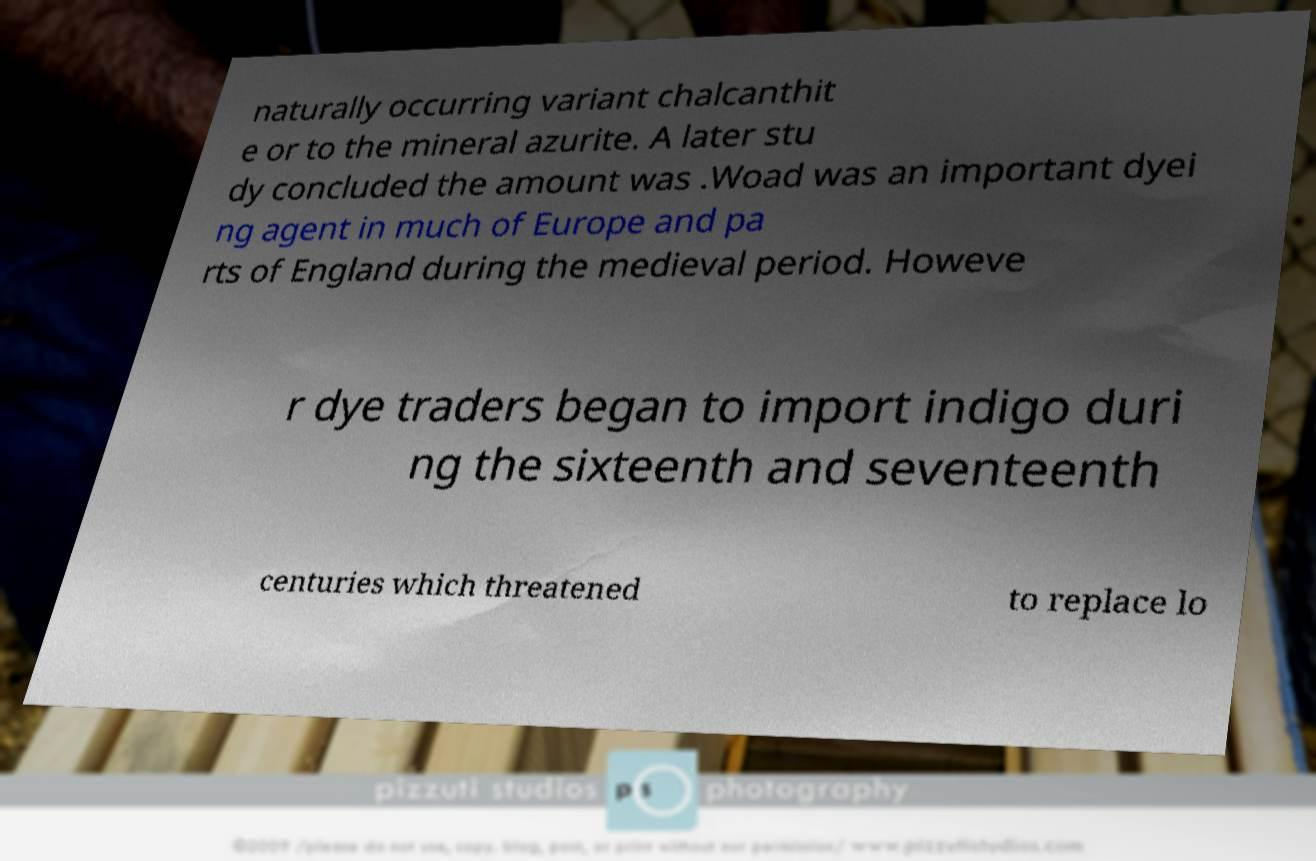Can you accurately transcribe the text from the provided image for me? naturally occurring variant chalcanthit e or to the mineral azurite. A later stu dy concluded the amount was .Woad was an important dyei ng agent in much of Europe and pa rts of England during the medieval period. Howeve r dye traders began to import indigo duri ng the sixteenth and seventeenth centuries which threatened to replace lo 